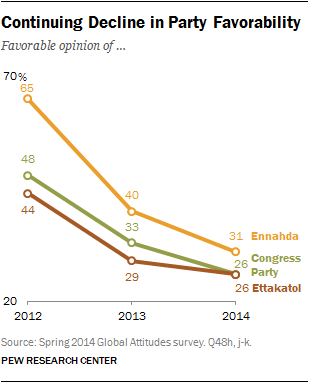Highlight a few significant elements in this photo. The green line represents the Congress Party in the given chart or graph. Ennahda had the highest favorability rating from 2012 to 2014, making it the party with the all-time high favorability. 